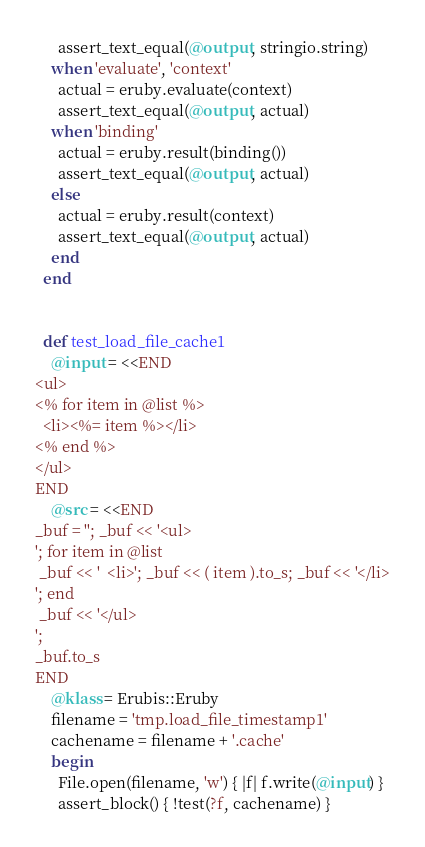<code> <loc_0><loc_0><loc_500><loc_500><_Ruby_>      assert_text_equal(@output, stringio.string)
    when 'evaluate', 'context'
      actual = eruby.evaluate(context)
      assert_text_equal(@output, actual)
    when 'binding'
      actual = eruby.result(binding())
      assert_text_equal(@output, actual)
    else
      actual = eruby.result(context)
      assert_text_equal(@output, actual)
    end
  end


  def test_load_file_cache1
    @input = <<END
<ul>
<% for item in @list %>
  <li><%= item %></li>
<% end %>
</ul>
END
    @src = <<END
_buf = ''; _buf << '<ul>
'; for item in @list 
 _buf << '  <li>'; _buf << ( item ).to_s; _buf << '</li>
'; end 
 _buf << '</ul>
';
_buf.to_s
END
    @klass = Erubis::Eruby
    filename = 'tmp.load_file_timestamp1'
    cachename = filename + '.cache'
    begin
      File.open(filename, 'w') { |f| f.write(@input) }
      assert_block() { !test(?f, cachename) }</code> 